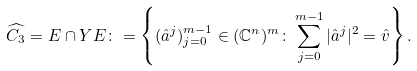<formula> <loc_0><loc_0><loc_500><loc_500>\widehat { C _ { 3 } } = E \cap Y E \colon = \left \{ ( \hat { a } ^ { j } ) _ { j = 0 } ^ { m - 1 } \in ( \mathbb { C } ^ { n } ) ^ { m } \colon \sum _ { j = 0 } ^ { m - 1 } | \hat { a } ^ { j } | ^ { 2 } = \hat { v } \right \} .</formula> 